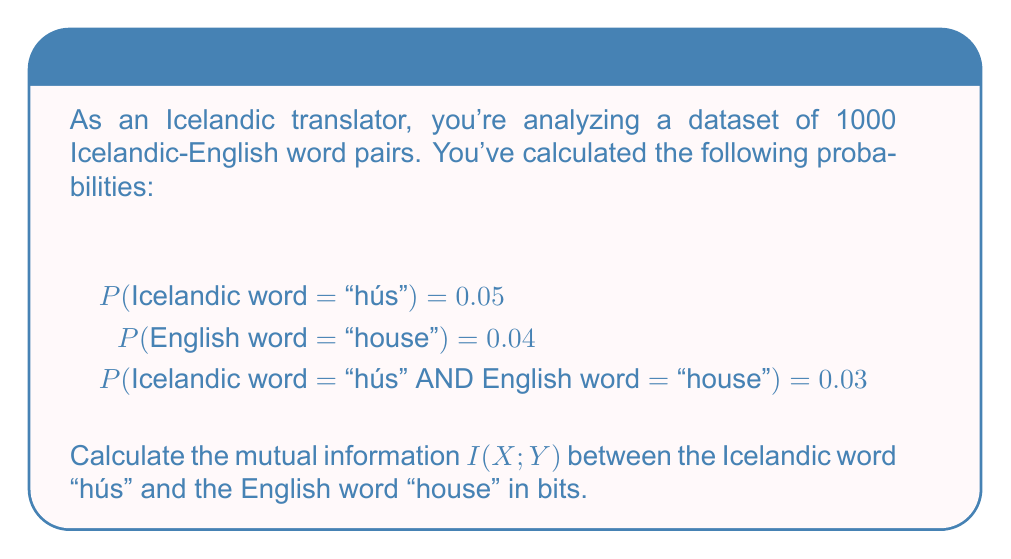Show me your answer to this math problem. To calculate the mutual information I(X;Y) between two events, we use the formula:

$$I(X;Y) = \log_2 \frac{P(X,Y)}{P(X)P(Y)}$$

Where:
X: Icelandic word "hús"
Y: English word "house"
P(X): Probability of X occurring
P(Y): Probability of Y occurring
P(X,Y): Joint probability of X and Y occurring together

Given:
P(X) = P(Icelandic word = "hús") = 0.05
P(Y) = P(English word = "house") = 0.04
P(X,Y) = P(Icelandic word = "hús" AND English word = "house") = 0.03

Step 1: Substitute the values into the formula:
$$I(X;Y) = \log_2 \frac{0.03}{0.05 \times 0.04}$$

Step 2: Calculate the denominator:
$$I(X;Y) = \log_2 \frac{0.03}{0.002}$$

Step 3: Divide inside the logarithm:
$$I(X;Y) = \log_2 15$$

Step 4: Calculate the logarithm:
$$I(X;Y) = 3.906890595 \text{ bits}$$

Therefore, the mutual information between "hús" and "house" is approximately 3.91 bits.
Answer: 3.91 bits 